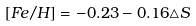Convert formula to latex. <formula><loc_0><loc_0><loc_500><loc_500>[ F e / H ] = - 0 . 2 3 - 0 . 1 6 \triangle S</formula> 